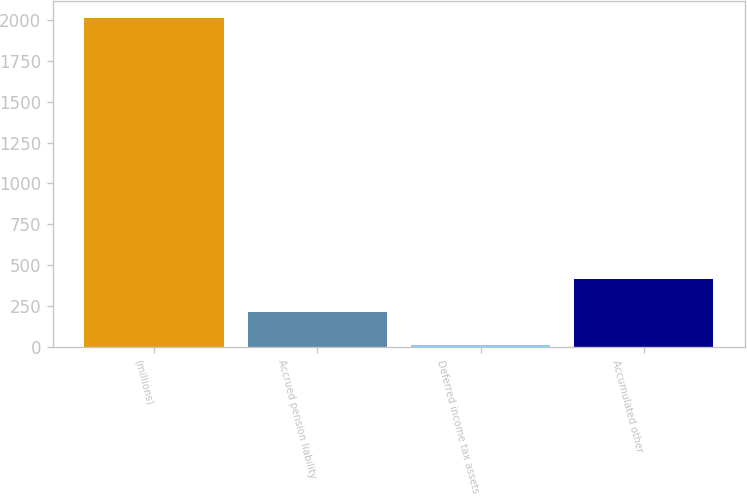Convert chart. <chart><loc_0><loc_0><loc_500><loc_500><bar_chart><fcel>(millions)<fcel>Accrued pension liability<fcel>Deferred income tax assets<fcel>Accumulated other<nl><fcel>2015<fcel>213.56<fcel>13.4<fcel>413.72<nl></chart> 